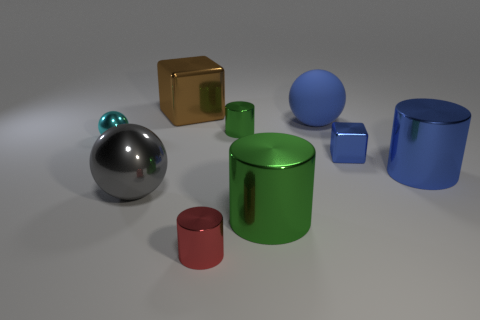Subtract all red cylinders. How many cylinders are left? 3 Subtract all yellow spheres. How many green cylinders are left? 2 Subtract all red metallic cylinders. How many cylinders are left? 3 Add 1 small brown objects. How many objects exist? 10 Subtract all yellow cylinders. Subtract all green blocks. How many cylinders are left? 4 Subtract all cylinders. How many objects are left? 5 Subtract all large shiny balls. Subtract all blue objects. How many objects are left? 5 Add 1 small blue metallic cubes. How many small blue metallic cubes are left? 2 Add 2 red objects. How many red objects exist? 3 Subtract 1 brown cubes. How many objects are left? 8 